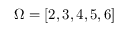<formula> <loc_0><loc_0><loc_500><loc_500>\Omega = [ 2 , 3 , 4 , 5 , 6 ]</formula> 